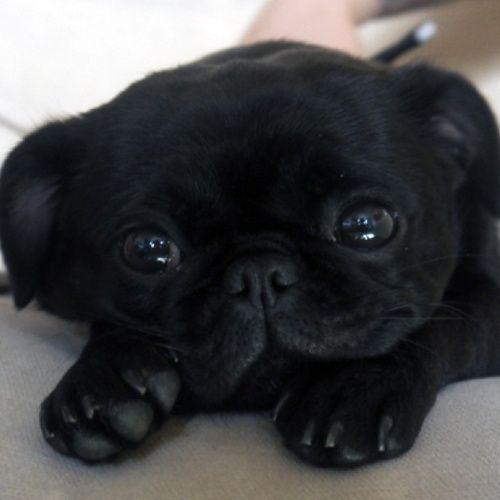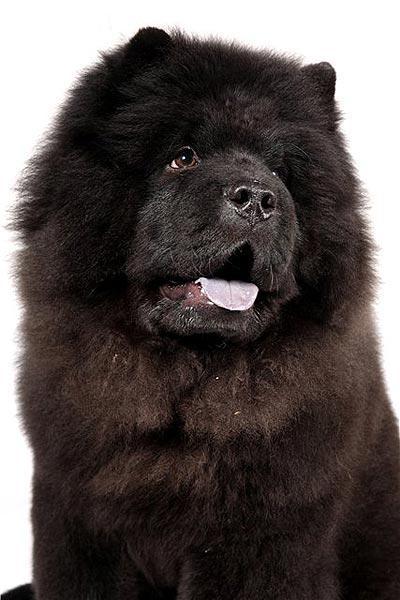The first image is the image on the left, the second image is the image on the right. Analyze the images presented: Is the assertion "There are only two dogs and no humans." valid? Answer yes or no. Yes. The first image is the image on the left, the second image is the image on the right. For the images shown, is this caption "An image shows rectangular wire 'mesh' behind one black chow dog." true? Answer yes or no. No. 